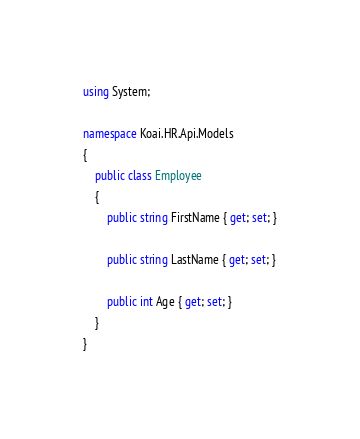Convert code to text. <code><loc_0><loc_0><loc_500><loc_500><_C#_>using System;

namespace Koai.HR.Api.Models
{
    public class Employee
    {
        public string FirstName { get; set; }

        public string LastName { get; set; }

        public int Age { get; set; }
    }
}
</code> 